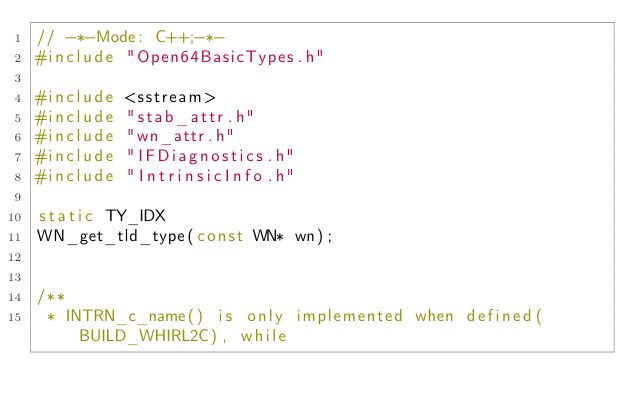Convert code to text. <code><loc_0><loc_0><loc_500><loc_500><_C++_>// -*-Mode: C++;-*-
#include "Open64BasicTypes.h"

#include <sstream>
#include "stab_attr.h"
#include "wn_attr.h"
#include "IFDiagnostics.h"
#include "IntrinsicInfo.h"

static TY_IDX
WN_get_tld_type(const WN* wn);


/**
 * INTRN_c_name() is only implemented when defined(BUILD_WHIRL2C), while</code> 